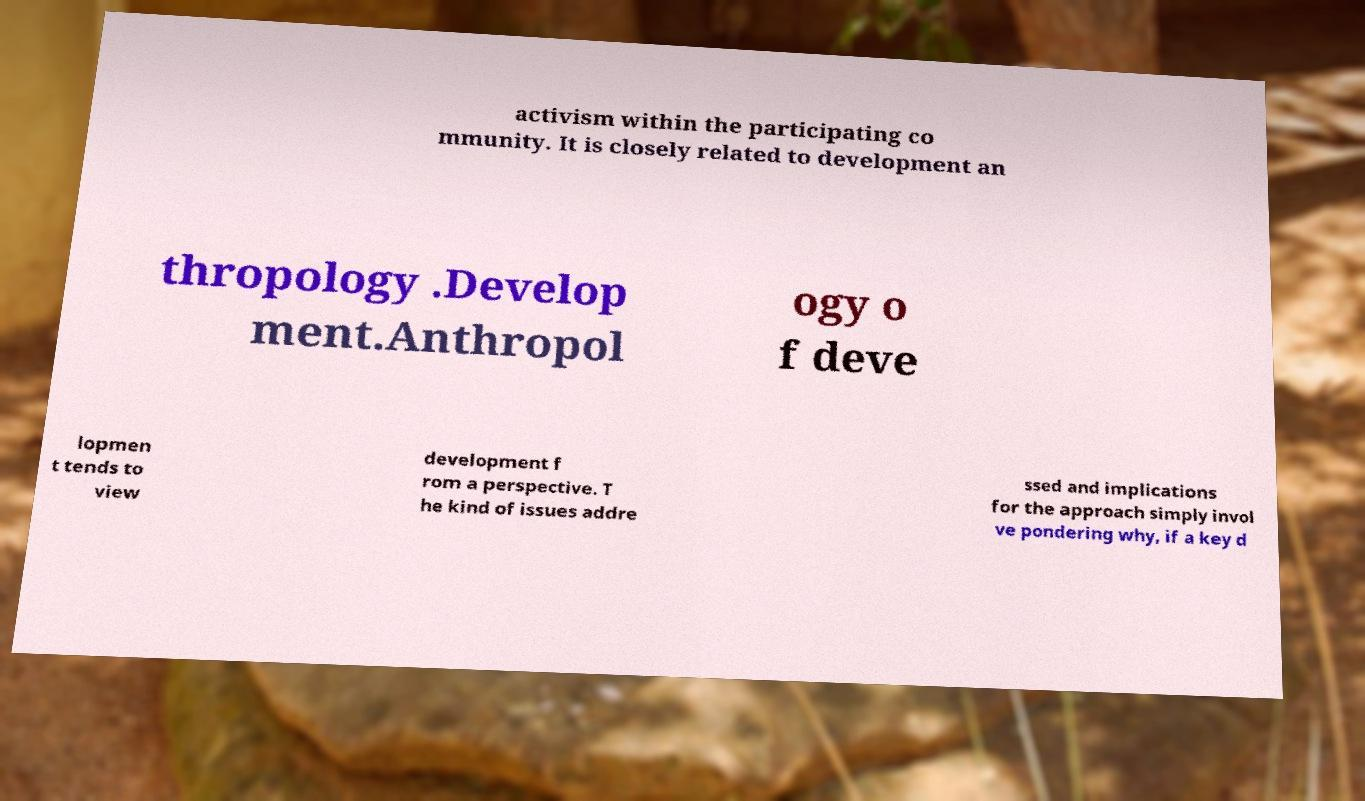Could you assist in decoding the text presented in this image and type it out clearly? activism within the participating co mmunity. It is closely related to development an thropology .Develop ment.Anthropol ogy o f deve lopmen t tends to view development f rom a perspective. T he kind of issues addre ssed and implications for the approach simply invol ve pondering why, if a key d 